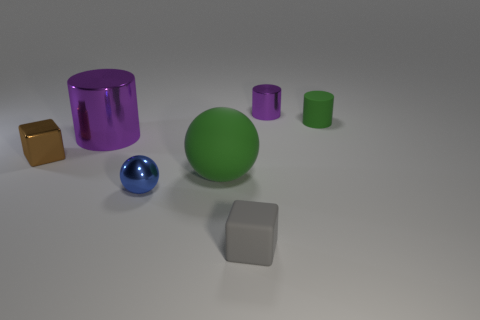Are there any matte spheres of the same color as the shiny ball?
Provide a succinct answer. No. There is a purple cylinder behind the rubber cylinder; is it the same size as the brown shiny block?
Offer a very short reply. Yes. Are there fewer large things than brown metal things?
Your answer should be very brief. No. Is there a purple object that has the same material as the blue object?
Your answer should be compact. Yes. What shape is the small rubber object that is behind the tiny brown shiny object?
Give a very brief answer. Cylinder. Does the cylinder that is on the left side of the small blue thing have the same color as the rubber ball?
Ensure brevity in your answer.  No. Are there fewer rubber objects behind the blue shiny sphere than small brown blocks?
Keep it short and to the point. No. The tiny cube that is made of the same material as the big ball is what color?
Ensure brevity in your answer.  Gray. There is a shiny thing that is behind the green cylinder; what size is it?
Make the answer very short. Small. Are the big cylinder and the small brown object made of the same material?
Give a very brief answer. Yes. 